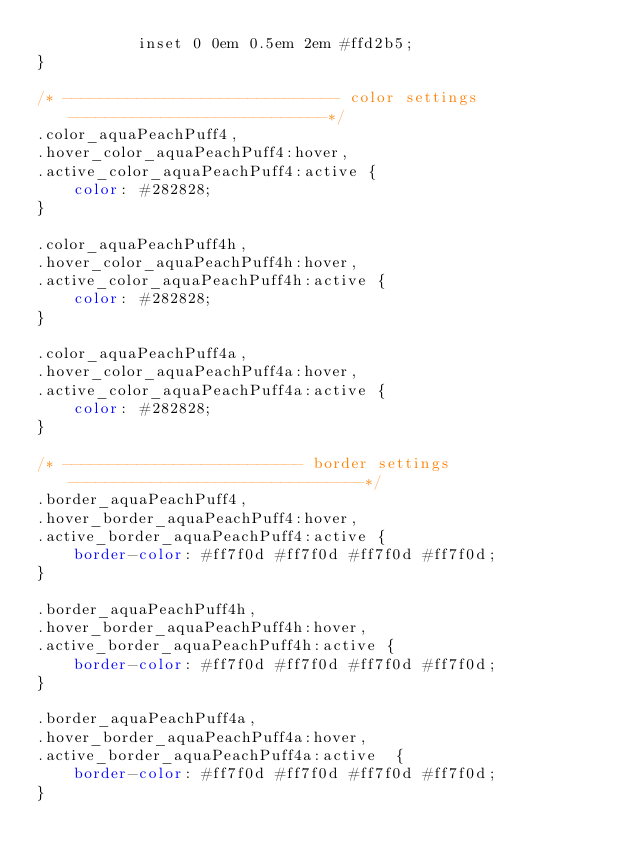<code> <loc_0><loc_0><loc_500><loc_500><_CSS_>           inset 0 0em 0.5em 2em #ffd2b5;
}

/* ------------------------------ color settings ----------------------------*/
.color_aquaPeachPuff4,
.hover_color_aquaPeachPuff4:hover,
.active_color_aquaPeachPuff4:active {
    color: #282828;
}

.color_aquaPeachPuff4h,
.hover_color_aquaPeachPuff4h:hover,
.active_color_aquaPeachPuff4h:active {
    color: #282828;
}

.color_aquaPeachPuff4a,
.hover_color_aquaPeachPuff4a:hover,
.active_color_aquaPeachPuff4a:active {
    color: #282828;
}

/* -------------------------- border settings --------------------------------*/
.border_aquaPeachPuff4,
.hover_border_aquaPeachPuff4:hover,
.active_border_aquaPeachPuff4:active {
    border-color: #ff7f0d #ff7f0d #ff7f0d #ff7f0d;
}

.border_aquaPeachPuff4h,
.hover_border_aquaPeachPuff4h:hover,
.active_border_aquaPeachPuff4h:active {
    border-color: #ff7f0d #ff7f0d #ff7f0d #ff7f0d;
}

.border_aquaPeachPuff4a,
.hover_border_aquaPeachPuff4a:hover,
.active_border_aquaPeachPuff4a:active  {
    border-color: #ff7f0d #ff7f0d #ff7f0d #ff7f0d;
}

</code> 